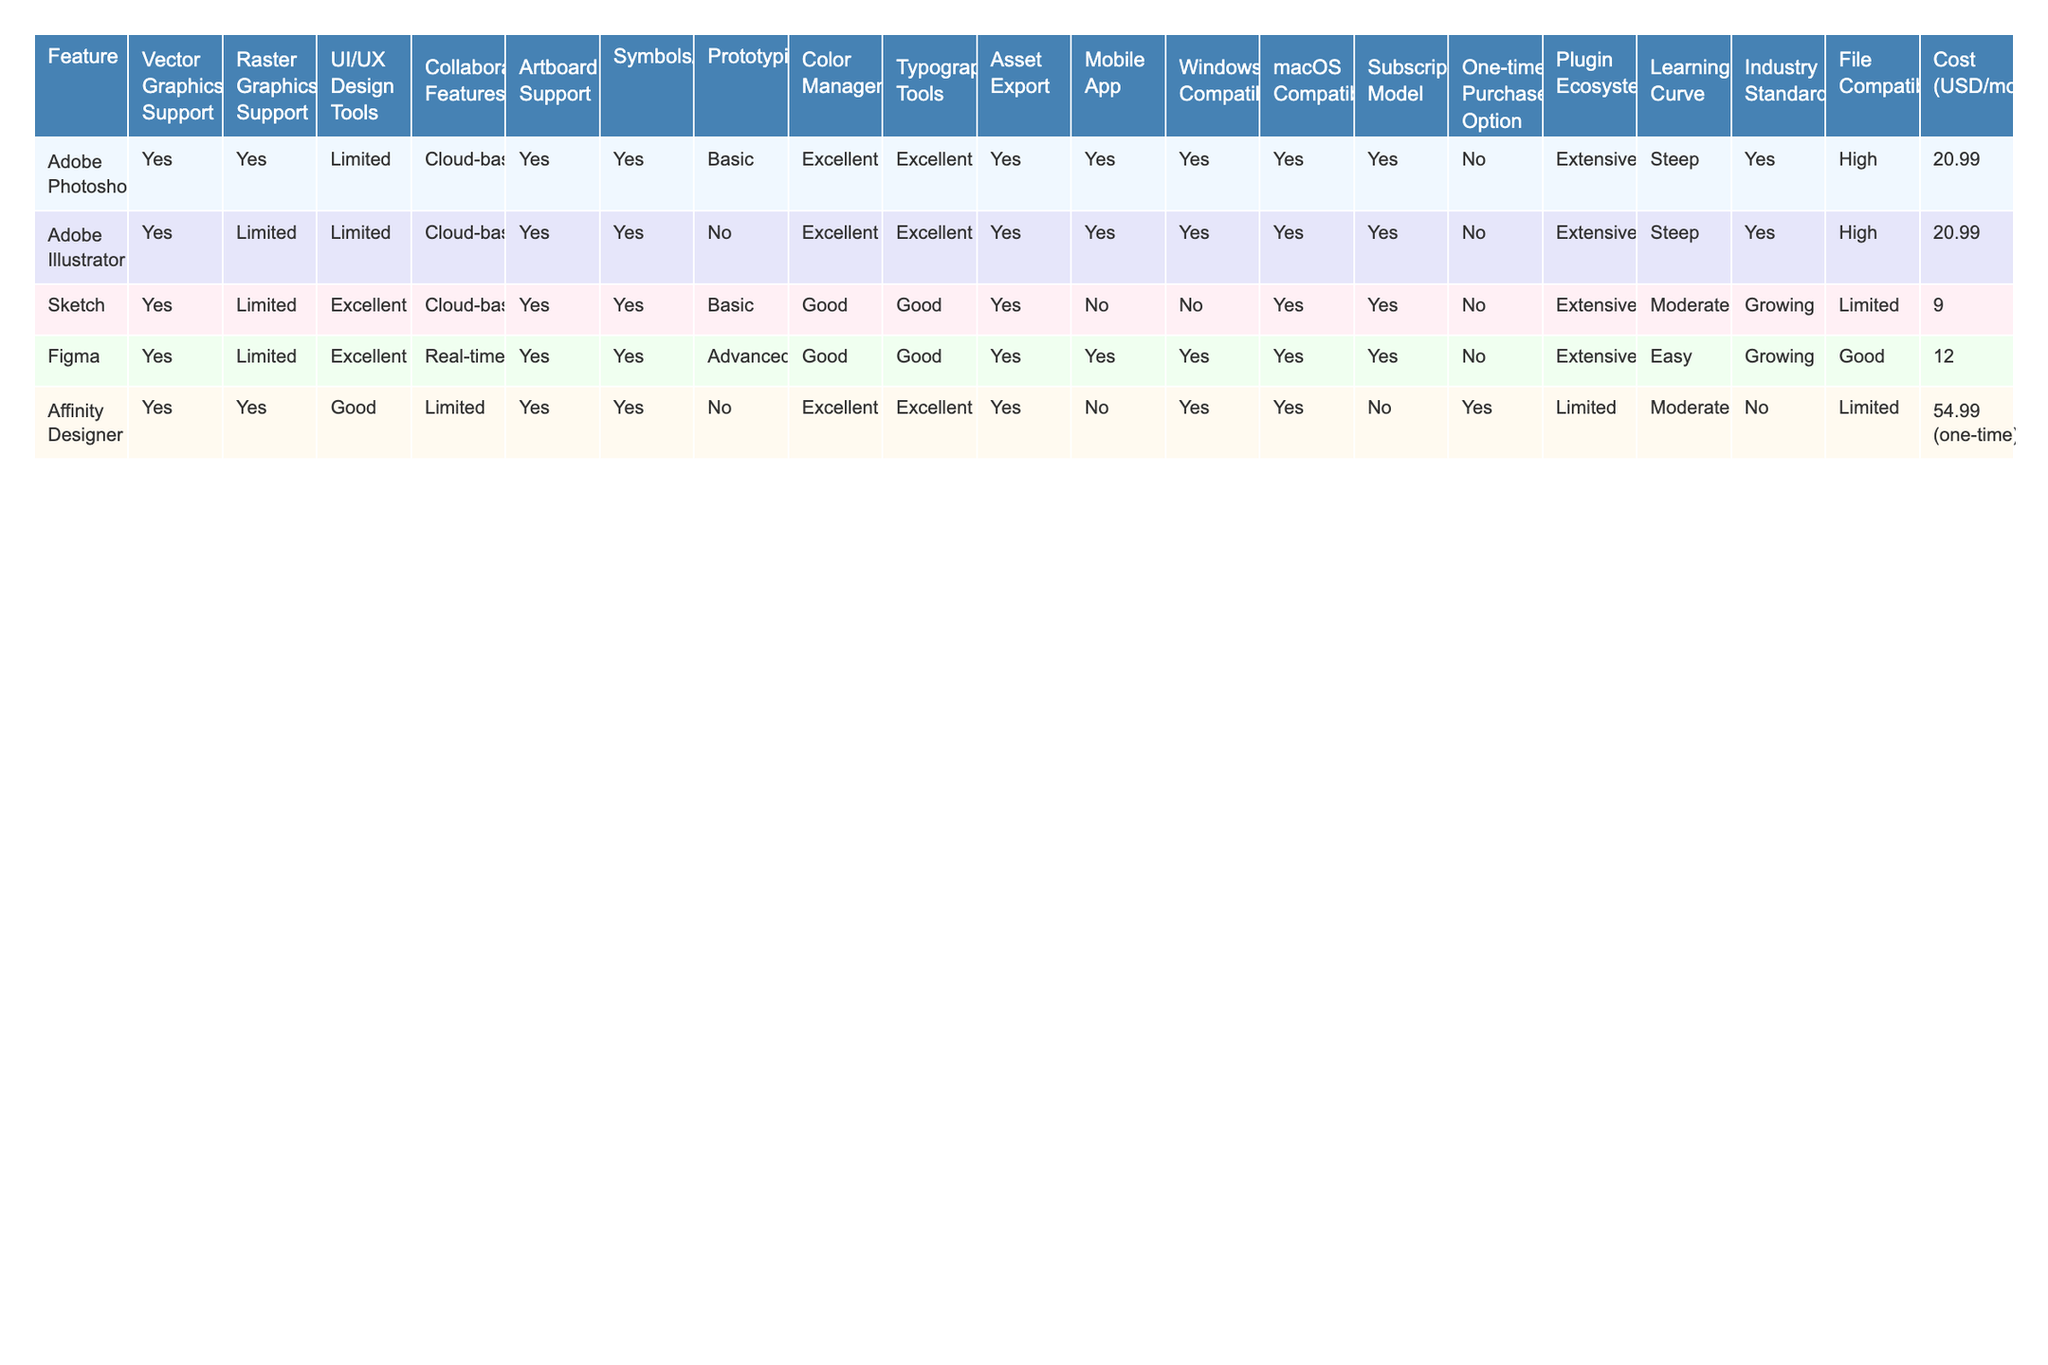What design software provides advanced prototyping capabilities? By looking at the feature row for prototyping in the table, we see that only Figma offers advanced prototyping capabilities, while others have basic or no support.
Answer: Figma Which software has a one-time purchase option? The table shows that only Affinity Designer has a one-time purchase option, while all other software operates on a subscription model.
Answer: Affinity Designer How many design software options provide excellent color management? The features row indicates that Adobe Photoshop, Adobe Illustrator, and Affinity Designer provide excellent color management. Therefore, there are three software options with this feature.
Answer: 3 Is Adobe Illustrator compatible with Windows? The table indicates that Adobe Illustrator has Windows compatibility listed as "Yes."
Answer: Yes Which software supports real-time collaborative features? The collaborative features row shows that Figma is the only software with real-time collaboration capabilities.
Answer: Figma How many software platforms have limited raster graphics support? From the raster graphics support row, we see that three software platforms—Adobe Illustrator, Sketch, and Figma—have limited raster graphics support.
Answer: 3 What features does Sketch excel in compared to others? By evaluating the UI/UX design tools row, Sketch stands out with excellent capabilities, not matched by others, which are limited or good.
Answer: UI/UX design tools Which software has the steepest learning curve? The learning curve row shows that both Adobe Photoshop and Adobe Illustrator are noted to have a steep learning curve.
Answer: Adobe Photoshop and Adobe Illustrator What is the average cost of the subscription model among the listed software (excluding Affinity Designer)? The subscription costs for Adobe Photoshop, Adobe Illustrator, Sketch, and Figma are 20.99, 20.99, 9, and 12, respectively. The total is 20.99 + 20.99 + 9 + 12 = 63.98, with an average of 63.98 / 4 = 15.995, rounded to 16.
Answer: 16 Does Affinity Designer support collaborative features? The table indicates that Affinity Designer has limited collaborative features, which means it does not fully support real-time collaboration like some others.
Answer: No 